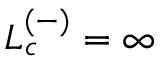Convert formula to latex. <formula><loc_0><loc_0><loc_500><loc_500>L _ { c } ^ { ( - ) } = \infty</formula> 